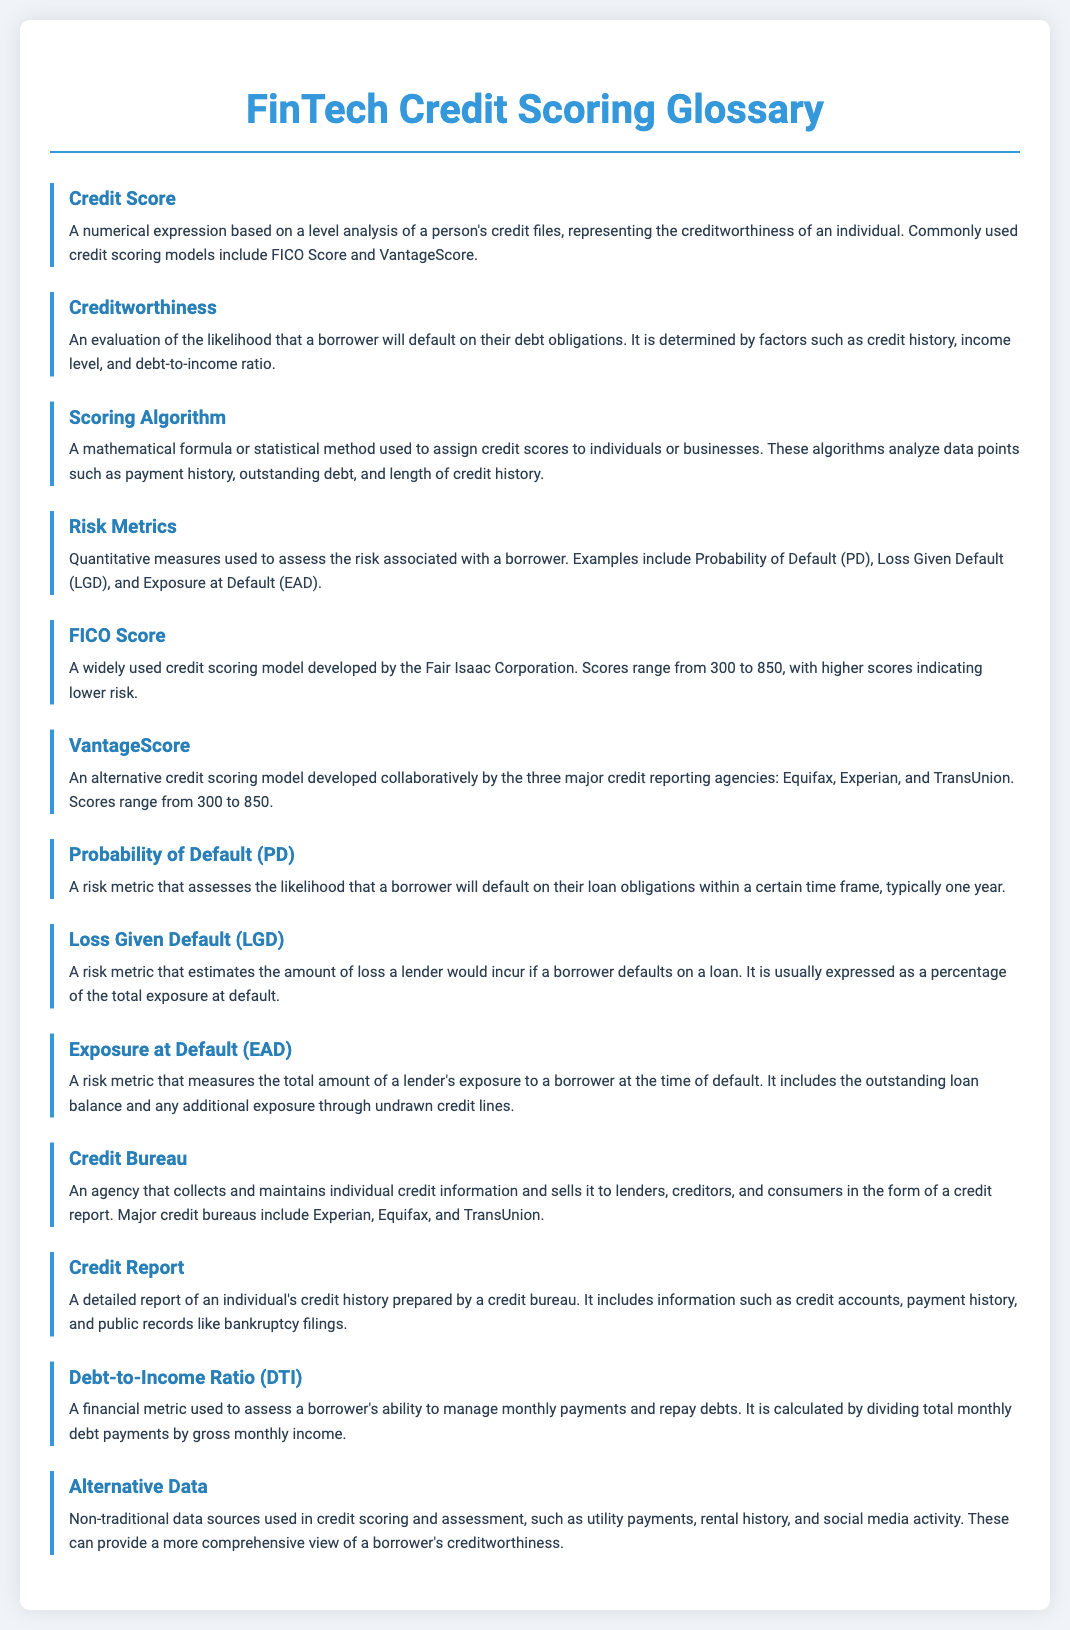What is a Credit Score? A Credit Score is a numerical expression based on a level analysis of a person's credit files, representing the creditworthiness of an individual.
Answer: A numerical expression based on a level analysis of a person's credit files What does Creditworthiness evaluate? Creditworthiness evaluates the likelihood that a borrower will default on their debt obligations.
Answer: The likelihood that a borrower will default on their debt obligations What scoring models are commonly used? The commonly used credit scoring models mentioned in the document are FICO Score and VantageScore.
Answer: FICO Score and VantageScore What does the acronym PD stand for? The acronym PD stands for Probability of Default, which is a risk metric that assesses the likelihood of default.
Answer: Probability of Default What is the range of a FICO Score? A FICO Score ranges from 300 to 850.
Answer: 300 to 850 What does DTI stand for? DTI stands for Debt-to-Income Ratio, which assesses a borrower's ability to manage monthly payments.
Answer: Debt-to-Income Ratio How is Loss Given Default expressed? Loss Given Default is usually expressed as a percentage of the total exposure at default.
Answer: As a percentage of the total exposure at default What types of data are included in Alternative Data? Alternative Data includes non-traditional sources such as utility payments, rental history, and social media activity.
Answer: Utility payments, rental history, and social media activity 